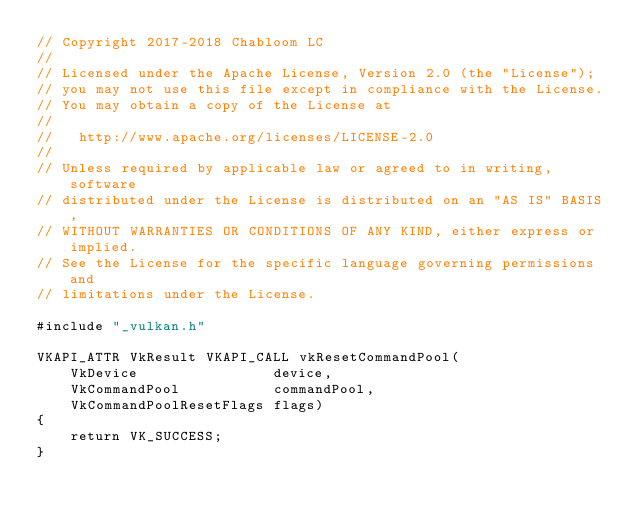<code> <loc_0><loc_0><loc_500><loc_500><_ObjectiveC_>// Copyright 2017-2018 Chabloom LC
//
// Licensed under the Apache License, Version 2.0 (the "License");
// you may not use this file except in compliance with the License.
// You may obtain a copy of the License at
//
//   http://www.apache.org/licenses/LICENSE-2.0
//
// Unless required by applicable law or agreed to in writing, software
// distributed under the License is distributed on an "AS IS" BASIS,
// WITHOUT WARRANTIES OR CONDITIONS OF ANY KIND, either express or implied.
// See the License for the specific language governing permissions and
// limitations under the License.

#include "_vulkan.h"

VKAPI_ATTR VkResult VKAPI_CALL vkResetCommandPool(
    VkDevice                device,
    VkCommandPool           commandPool,
    VkCommandPoolResetFlags flags)
{
    return VK_SUCCESS;
}
</code> 